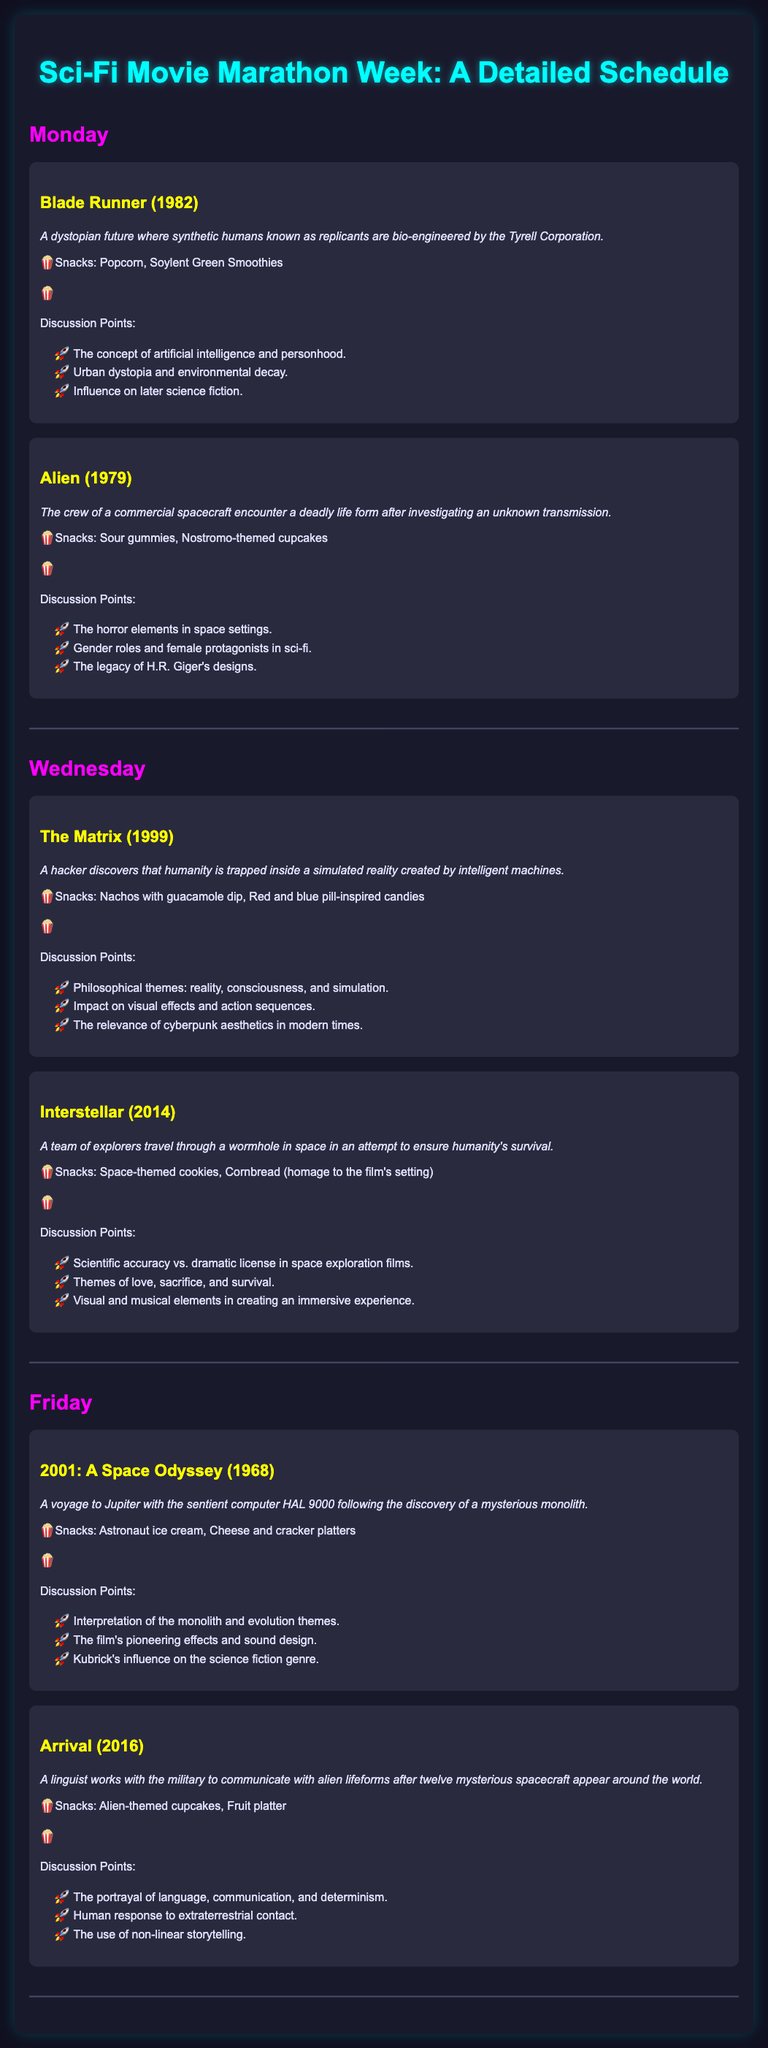What is the title of the document? The title of the document is given at the top, which is "Sci-Fi Movie Marathon Week: A Detailed Schedule."
Answer: Sci-Fi Movie Marathon Week: A Detailed Schedule How many films are shown on Monday? The document lists two films for Monday, which are "Blade Runner" and "Alien."
Answer: 2 What snacks are associated with "Interstellar"? The snacks listed for "Interstellar" include space-themed cookies and cornbread.
Answer: Space-themed cookies, Cornbread What year was "Arrival" released? The document specifies the release year of "Arrival" as 2016, as mentioned alongside the film description.
Answer: 2016 What is a discussion point for "Alien"? One of the discussion points listed for "Alien" is "Gender roles and female protagonists in sci-fi."
Answer: Gender roles and female protagonists in sci-fi Which film has the theme of artificial intelligence? The film "Blade Runner" is centered around artificial intelligence, as described in its summary.
Answer: Blade Runner What type of cookies are mentioned as snacks for "2001: A Space Odyssey"? The document states that astronaut ice cream and cheese and cracker platters are the snacks for "2001: A Space Odyssey."
Answer: Astronaut ice cream What is one philosophical theme discussed in "The Matrix"? The document mentions that "reality, consciousness, and simulation" are philosophical themes discussed in "The Matrix."
Answer: Reality, consciousness, and simulation What is the main focus of the film "Arrival"? The film "Arrival" focuses on a linguist working with the military to communicate with alien lifeforms.
Answer: Communicate with alien lifeforms 